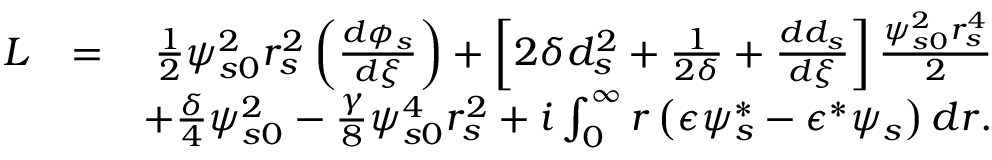<formula> <loc_0><loc_0><loc_500><loc_500>\begin{array} { r l r } { L } & { = } & { \frac { 1 } { 2 } \psi _ { s 0 } ^ { 2 } r _ { s } ^ { 2 } \left ( \frac { d \phi _ { s } } { d \xi } \right ) + \left [ 2 \delta d _ { s } ^ { 2 } + \frac { 1 } { 2 \delta } + \frac { d d _ { s } } { d \xi } \right ] \frac { \psi _ { s 0 } ^ { 2 } r _ { s } ^ { 4 } } { 2 } } \\ & { + \frac { \delta } { 4 } \psi _ { s 0 } ^ { 2 } - \frac { \gamma } { 8 } \psi _ { s 0 } ^ { 4 } r _ { s } ^ { 2 } + i \int _ { 0 } ^ { \infty } r \left ( \epsilon \psi _ { s } ^ { * } - \epsilon ^ { * } \psi _ { s } \right ) d r . } \end{array}</formula> 